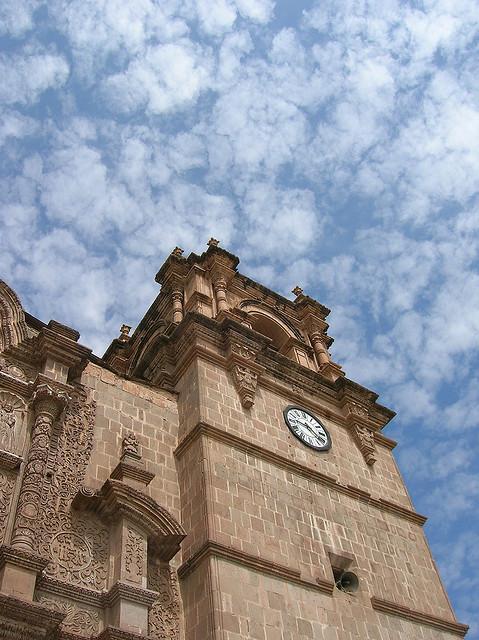How many light color cars are there?
Give a very brief answer. 0. 